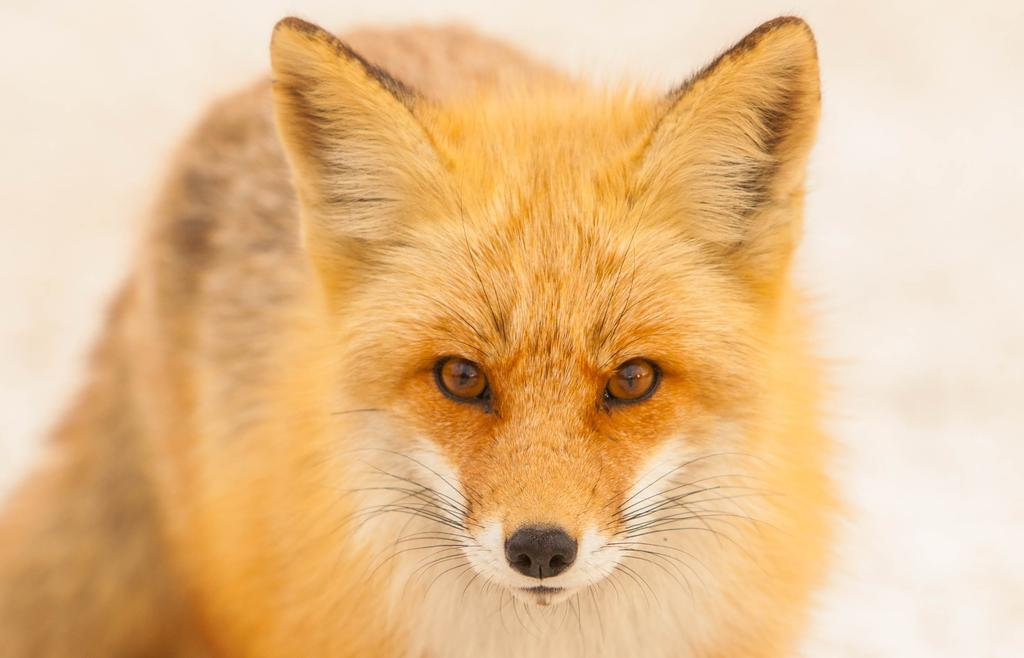What type of living creature is present in the image? There is an animal in the image. Is there a cellar visible in the image? There is no mention of a cellar in the provided facts, and therefore it cannot be determined if one is present in the image. What type of beast can be seen in the image? The term "beast" is not mentioned in the provided facts, and therefore it cannot be determined if one is present in the image. 